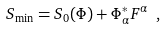<formula> <loc_0><loc_0><loc_500><loc_500>S _ { \min } = S _ { 0 } ( \Phi ) + \Phi ^ { * } _ { \alpha } F ^ { \alpha } \ ,</formula> 